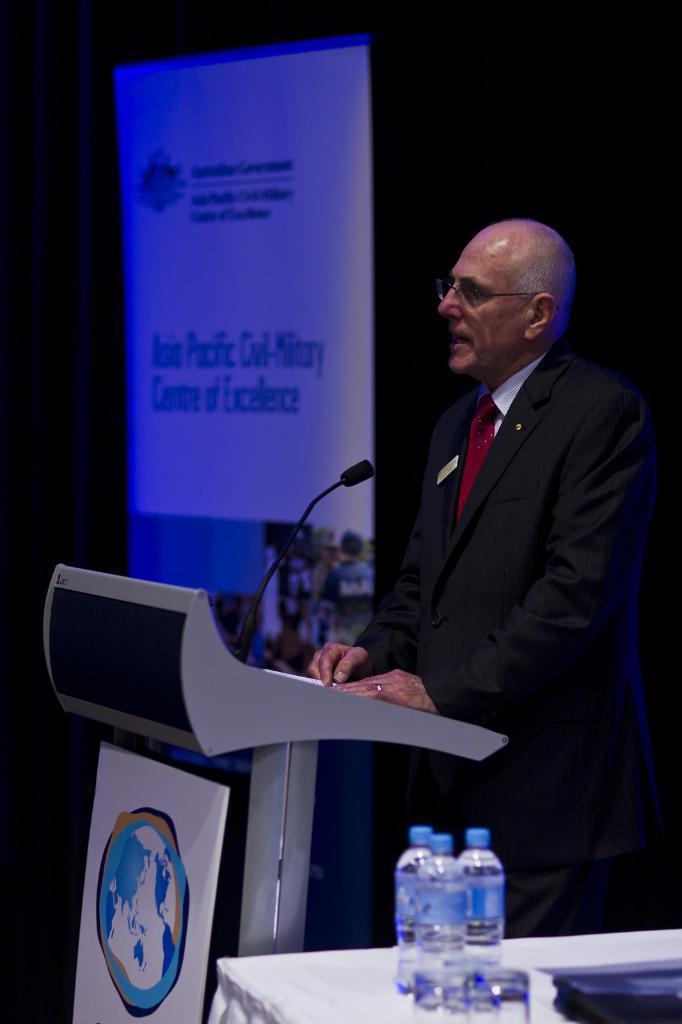How would you summarize this image in a sentence or two? This picture is clicked inside. In the foreground there is a table on the top of which a glass, water bottles and some items are placed. On the right there is a man wearing suit and standing and we can see a microphone attached to the podium. In the background there is a banner on which we can see the text. 